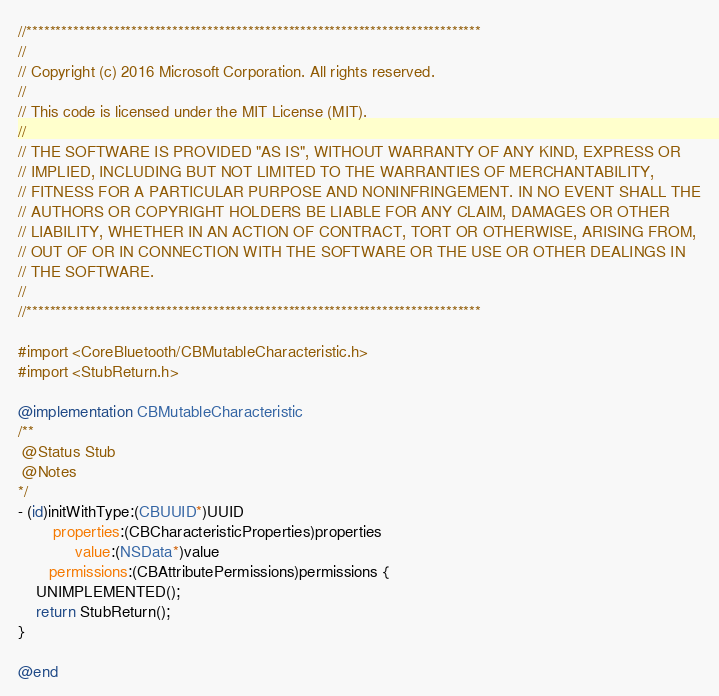Convert code to text. <code><loc_0><loc_0><loc_500><loc_500><_ObjectiveC_>//******************************************************************************
//
// Copyright (c) 2016 Microsoft Corporation. All rights reserved.
//
// This code is licensed under the MIT License (MIT).
//
// THE SOFTWARE IS PROVIDED "AS IS", WITHOUT WARRANTY OF ANY KIND, EXPRESS OR
// IMPLIED, INCLUDING BUT NOT LIMITED TO THE WARRANTIES OF MERCHANTABILITY,
// FITNESS FOR A PARTICULAR PURPOSE AND NONINFRINGEMENT. IN NO EVENT SHALL THE
// AUTHORS OR COPYRIGHT HOLDERS BE LIABLE FOR ANY CLAIM, DAMAGES OR OTHER
// LIABILITY, WHETHER IN AN ACTION OF CONTRACT, TORT OR OTHERWISE, ARISING FROM,
// OUT OF OR IN CONNECTION WITH THE SOFTWARE OR THE USE OR OTHER DEALINGS IN
// THE SOFTWARE.
//
//******************************************************************************

#import <CoreBluetooth/CBMutableCharacteristic.h>
#import <StubReturn.h>

@implementation CBMutableCharacteristic
/**
 @Status Stub
 @Notes
*/
- (id)initWithType:(CBUUID*)UUID
        properties:(CBCharacteristicProperties)properties
             value:(NSData*)value
       permissions:(CBAttributePermissions)permissions {
    UNIMPLEMENTED();
    return StubReturn();
}

@end
</code> 